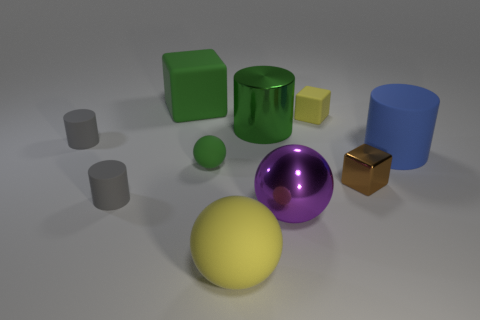Subtract all tiny rubber blocks. How many blocks are left? 2 Subtract 2 cylinders. How many cylinders are left? 2 Subtract all red cubes. How many gray cylinders are left? 2 Subtract all green blocks. How many blocks are left? 2 Subtract all cylinders. How many objects are left? 6 Add 8 big purple spheres. How many big purple spheres are left? 9 Add 1 tiny red metal blocks. How many tiny red metal blocks exist? 1 Subtract 0 yellow cylinders. How many objects are left? 10 Subtract all green spheres. Subtract all red cylinders. How many spheres are left? 2 Subtract all small green shiny balls. Subtract all metal things. How many objects are left? 7 